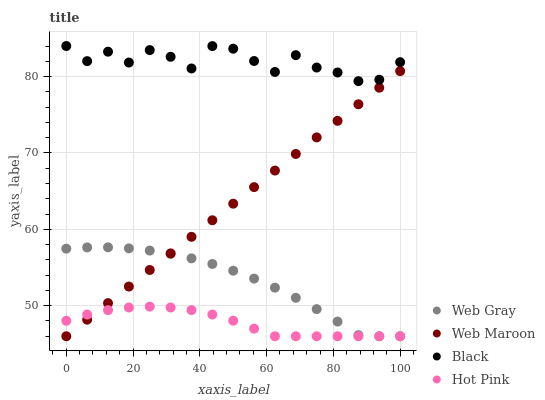Does Hot Pink have the minimum area under the curve?
Answer yes or no. Yes. Does Black have the maximum area under the curve?
Answer yes or no. Yes. Does Web Gray have the minimum area under the curve?
Answer yes or no. No. Does Web Gray have the maximum area under the curve?
Answer yes or no. No. Is Web Maroon the smoothest?
Answer yes or no. Yes. Is Black the roughest?
Answer yes or no. Yes. Is Web Gray the smoothest?
Answer yes or no. No. Is Web Gray the roughest?
Answer yes or no. No. Does Web Gray have the lowest value?
Answer yes or no. Yes. Does Black have the highest value?
Answer yes or no. Yes. Does Web Gray have the highest value?
Answer yes or no. No. Is Web Maroon less than Black?
Answer yes or no. Yes. Is Black greater than Hot Pink?
Answer yes or no. Yes. Does Hot Pink intersect Web Maroon?
Answer yes or no. Yes. Is Hot Pink less than Web Maroon?
Answer yes or no. No. Is Hot Pink greater than Web Maroon?
Answer yes or no. No. Does Web Maroon intersect Black?
Answer yes or no. No. 